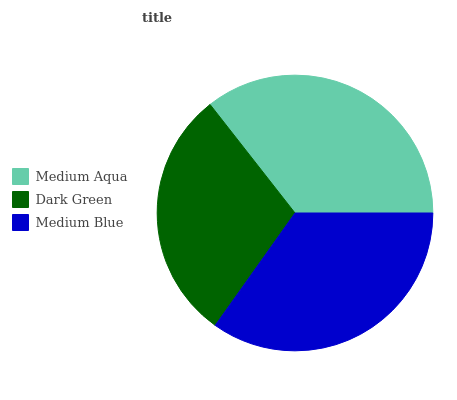Is Dark Green the minimum?
Answer yes or no. Yes. Is Medium Aqua the maximum?
Answer yes or no. Yes. Is Medium Blue the minimum?
Answer yes or no. No. Is Medium Blue the maximum?
Answer yes or no. No. Is Medium Blue greater than Dark Green?
Answer yes or no. Yes. Is Dark Green less than Medium Blue?
Answer yes or no. Yes. Is Dark Green greater than Medium Blue?
Answer yes or no. No. Is Medium Blue less than Dark Green?
Answer yes or no. No. Is Medium Blue the high median?
Answer yes or no. Yes. Is Medium Blue the low median?
Answer yes or no. Yes. Is Medium Aqua the high median?
Answer yes or no. No. Is Dark Green the low median?
Answer yes or no. No. 